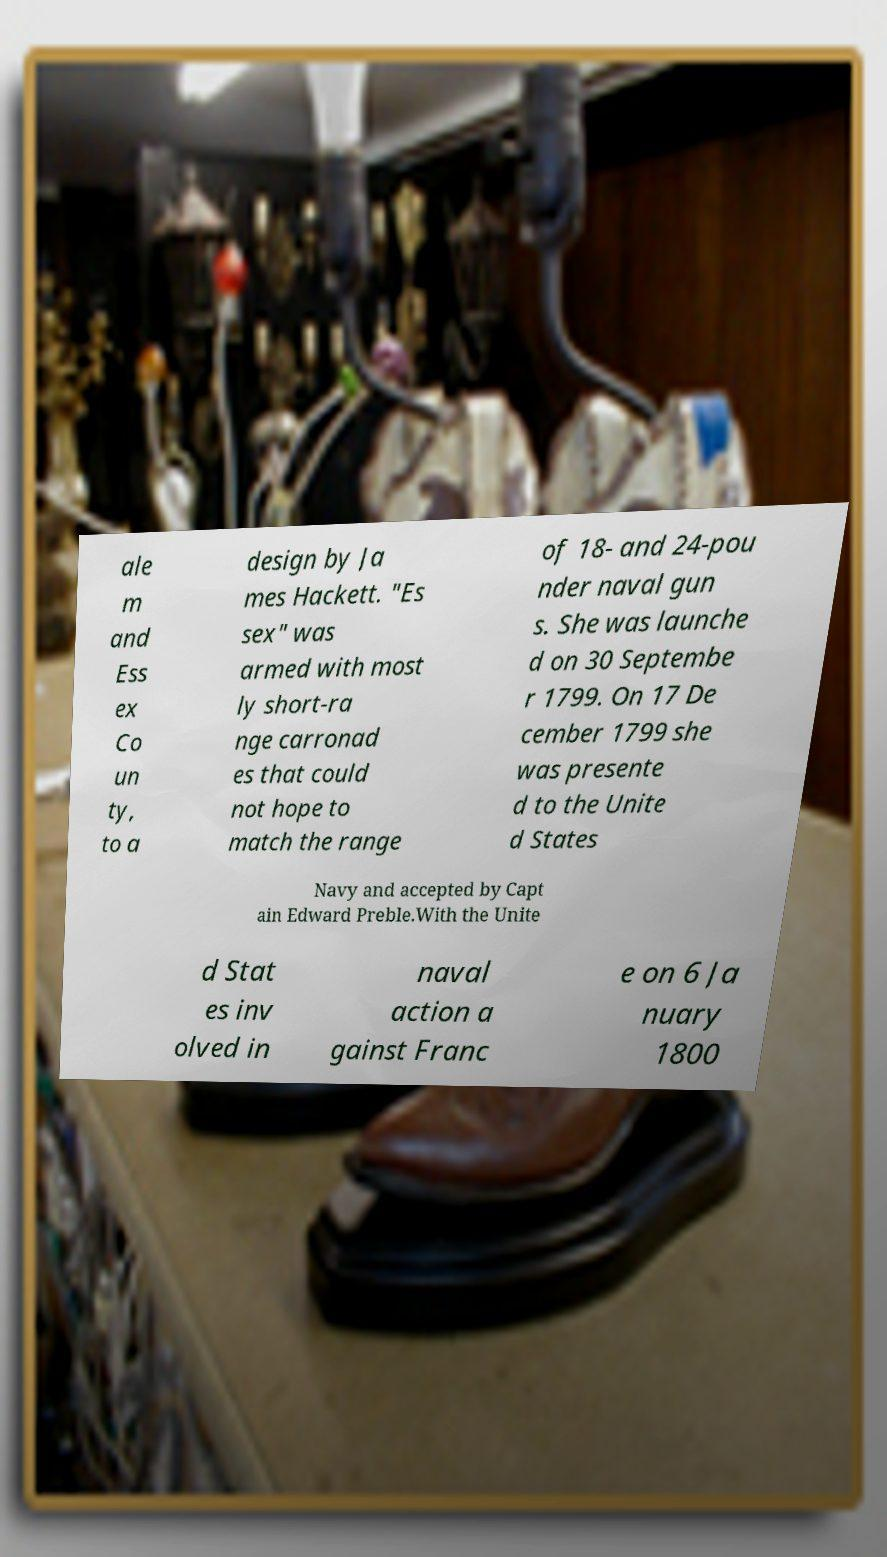What messages or text are displayed in this image? I need them in a readable, typed format. ale m and Ess ex Co un ty, to a design by Ja mes Hackett. "Es sex" was armed with most ly short-ra nge carronad es that could not hope to match the range of 18- and 24-pou nder naval gun s. She was launche d on 30 Septembe r 1799. On 17 De cember 1799 she was presente d to the Unite d States Navy and accepted by Capt ain Edward Preble.With the Unite d Stat es inv olved in naval action a gainst Franc e on 6 Ja nuary 1800 